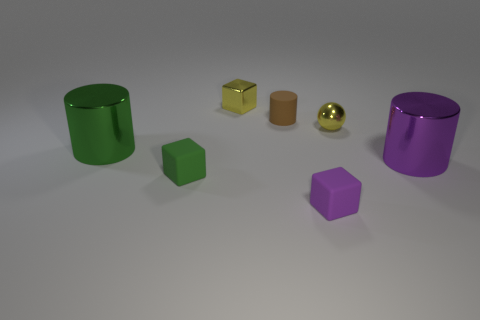Add 2 small green matte cubes. How many objects exist? 9 Add 3 tiny rubber cubes. How many tiny rubber cubes are left? 5 Add 5 small shiny objects. How many small shiny objects exist? 7 Subtract all yellow blocks. How many blocks are left? 2 Subtract 0 gray cylinders. How many objects are left? 7 Subtract all blocks. How many objects are left? 4 Subtract 1 blocks. How many blocks are left? 2 Subtract all yellow cylinders. Subtract all gray balls. How many cylinders are left? 3 Subtract all cyan balls. How many purple cylinders are left? 1 Subtract all small gray cylinders. Subtract all large purple objects. How many objects are left? 6 